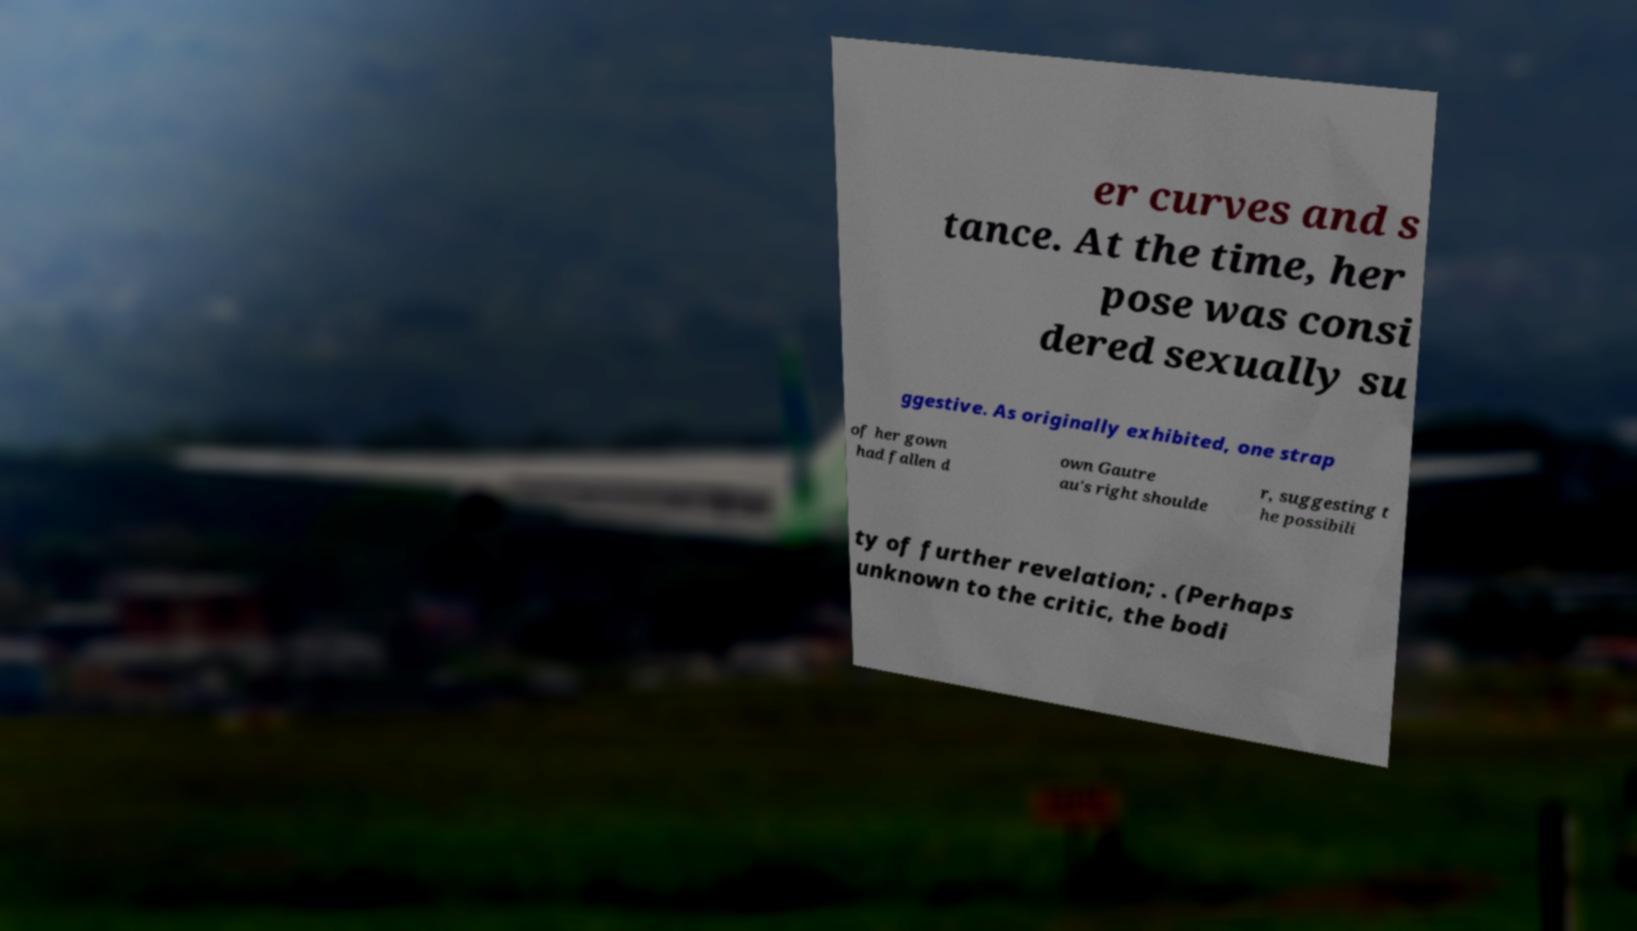Could you extract and type out the text from this image? er curves and s tance. At the time, her pose was consi dered sexually su ggestive. As originally exhibited, one strap of her gown had fallen d own Gautre au's right shoulde r, suggesting t he possibili ty of further revelation; . (Perhaps unknown to the critic, the bodi 